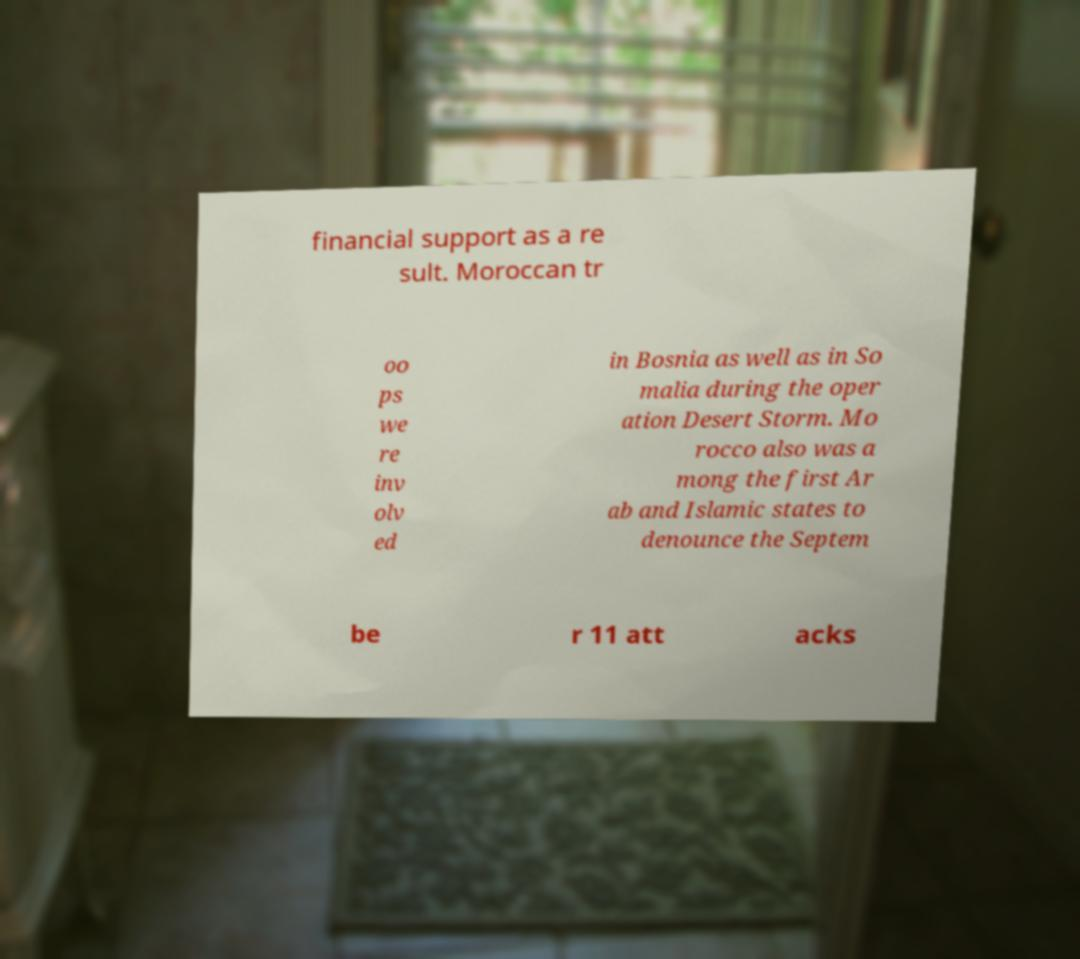Can you accurately transcribe the text from the provided image for me? financial support as a re sult. Moroccan tr oo ps we re inv olv ed in Bosnia as well as in So malia during the oper ation Desert Storm. Mo rocco also was a mong the first Ar ab and Islamic states to denounce the Septem be r 11 att acks 